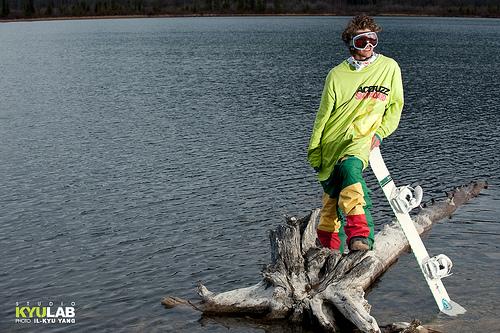Is the person wearing goggles?
Short answer required. Yes. What color is the person's shirt?
Quick response, please. Green. What is the person standing on?
Quick response, please. Log. 